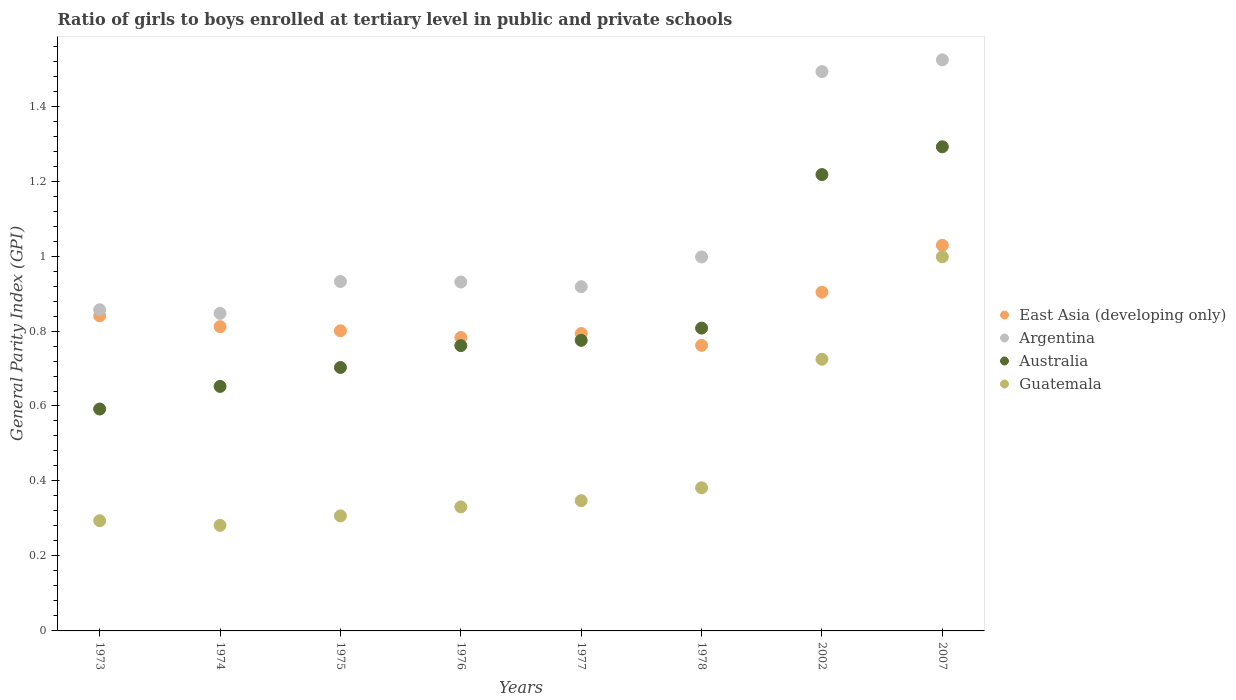How many different coloured dotlines are there?
Your answer should be very brief. 4. What is the general parity index in Australia in 2002?
Your answer should be compact. 1.22. Across all years, what is the maximum general parity index in East Asia (developing only)?
Provide a short and direct response. 1.03. Across all years, what is the minimum general parity index in Australia?
Provide a short and direct response. 0.59. In which year was the general parity index in Australia minimum?
Offer a very short reply. 1973. What is the total general parity index in East Asia (developing only) in the graph?
Provide a succinct answer. 6.72. What is the difference between the general parity index in Australia in 1978 and that in 2007?
Ensure brevity in your answer.  -0.48. What is the difference between the general parity index in Argentina in 1973 and the general parity index in East Asia (developing only) in 1976?
Provide a short and direct response. 0.07. What is the average general parity index in Guatemala per year?
Your answer should be compact. 0.46. In the year 2002, what is the difference between the general parity index in Australia and general parity index in Argentina?
Your response must be concise. -0.27. What is the ratio of the general parity index in Guatemala in 1974 to that in 1978?
Offer a very short reply. 0.74. Is the difference between the general parity index in Australia in 1973 and 1977 greater than the difference between the general parity index in Argentina in 1973 and 1977?
Ensure brevity in your answer.  No. What is the difference between the highest and the second highest general parity index in East Asia (developing only)?
Keep it short and to the point. 0.13. What is the difference between the highest and the lowest general parity index in Australia?
Make the answer very short. 0.7. In how many years, is the general parity index in Australia greater than the average general parity index in Australia taken over all years?
Your response must be concise. 2. Is it the case that in every year, the sum of the general parity index in East Asia (developing only) and general parity index in Argentina  is greater than the general parity index in Guatemala?
Make the answer very short. Yes. Is the general parity index in East Asia (developing only) strictly greater than the general parity index in Australia over the years?
Ensure brevity in your answer.  No. What is the difference between two consecutive major ticks on the Y-axis?
Provide a short and direct response. 0.2. Where does the legend appear in the graph?
Your response must be concise. Center right. How many legend labels are there?
Make the answer very short. 4. What is the title of the graph?
Provide a succinct answer. Ratio of girls to boys enrolled at tertiary level in public and private schools. What is the label or title of the X-axis?
Offer a very short reply. Years. What is the label or title of the Y-axis?
Keep it short and to the point. General Parity Index (GPI). What is the General Parity Index (GPI) in East Asia (developing only) in 1973?
Your response must be concise. 0.84. What is the General Parity Index (GPI) in Argentina in 1973?
Keep it short and to the point. 0.86. What is the General Parity Index (GPI) in Australia in 1973?
Make the answer very short. 0.59. What is the General Parity Index (GPI) in Guatemala in 1973?
Ensure brevity in your answer.  0.29. What is the General Parity Index (GPI) of East Asia (developing only) in 1974?
Your answer should be very brief. 0.81. What is the General Parity Index (GPI) in Argentina in 1974?
Your answer should be compact. 0.85. What is the General Parity Index (GPI) in Australia in 1974?
Provide a short and direct response. 0.65. What is the General Parity Index (GPI) of Guatemala in 1974?
Make the answer very short. 0.28. What is the General Parity Index (GPI) of East Asia (developing only) in 1975?
Give a very brief answer. 0.8. What is the General Parity Index (GPI) in Argentina in 1975?
Make the answer very short. 0.93. What is the General Parity Index (GPI) in Australia in 1975?
Ensure brevity in your answer.  0.7. What is the General Parity Index (GPI) in Guatemala in 1975?
Offer a terse response. 0.31. What is the General Parity Index (GPI) of East Asia (developing only) in 1976?
Give a very brief answer. 0.78. What is the General Parity Index (GPI) in Argentina in 1976?
Make the answer very short. 0.93. What is the General Parity Index (GPI) in Australia in 1976?
Offer a very short reply. 0.76. What is the General Parity Index (GPI) in Guatemala in 1976?
Provide a succinct answer. 0.33. What is the General Parity Index (GPI) of East Asia (developing only) in 1977?
Keep it short and to the point. 0.79. What is the General Parity Index (GPI) of Argentina in 1977?
Give a very brief answer. 0.92. What is the General Parity Index (GPI) in Australia in 1977?
Keep it short and to the point. 0.78. What is the General Parity Index (GPI) in Guatemala in 1977?
Offer a very short reply. 0.35. What is the General Parity Index (GPI) of East Asia (developing only) in 1978?
Keep it short and to the point. 0.76. What is the General Parity Index (GPI) of Argentina in 1978?
Give a very brief answer. 1. What is the General Parity Index (GPI) of Australia in 1978?
Keep it short and to the point. 0.81. What is the General Parity Index (GPI) in Guatemala in 1978?
Make the answer very short. 0.38. What is the General Parity Index (GPI) in East Asia (developing only) in 2002?
Provide a succinct answer. 0.9. What is the General Parity Index (GPI) of Argentina in 2002?
Ensure brevity in your answer.  1.49. What is the General Parity Index (GPI) of Australia in 2002?
Keep it short and to the point. 1.22. What is the General Parity Index (GPI) in Guatemala in 2002?
Offer a very short reply. 0.72. What is the General Parity Index (GPI) of East Asia (developing only) in 2007?
Your response must be concise. 1.03. What is the General Parity Index (GPI) of Argentina in 2007?
Ensure brevity in your answer.  1.52. What is the General Parity Index (GPI) in Australia in 2007?
Your answer should be very brief. 1.29. What is the General Parity Index (GPI) of Guatemala in 2007?
Offer a very short reply. 1. Across all years, what is the maximum General Parity Index (GPI) of East Asia (developing only)?
Keep it short and to the point. 1.03. Across all years, what is the maximum General Parity Index (GPI) in Argentina?
Make the answer very short. 1.52. Across all years, what is the maximum General Parity Index (GPI) in Australia?
Your answer should be very brief. 1.29. Across all years, what is the maximum General Parity Index (GPI) in Guatemala?
Offer a terse response. 1. Across all years, what is the minimum General Parity Index (GPI) in East Asia (developing only)?
Provide a short and direct response. 0.76. Across all years, what is the minimum General Parity Index (GPI) of Argentina?
Your response must be concise. 0.85. Across all years, what is the minimum General Parity Index (GPI) in Australia?
Provide a succinct answer. 0.59. Across all years, what is the minimum General Parity Index (GPI) of Guatemala?
Provide a succinct answer. 0.28. What is the total General Parity Index (GPI) of East Asia (developing only) in the graph?
Offer a terse response. 6.72. What is the total General Parity Index (GPI) of Argentina in the graph?
Provide a succinct answer. 8.5. What is the total General Parity Index (GPI) of Australia in the graph?
Offer a very short reply. 6.8. What is the total General Parity Index (GPI) in Guatemala in the graph?
Your response must be concise. 3.67. What is the difference between the General Parity Index (GPI) of East Asia (developing only) in 1973 and that in 1974?
Make the answer very short. 0.03. What is the difference between the General Parity Index (GPI) in Argentina in 1973 and that in 1974?
Give a very brief answer. 0.01. What is the difference between the General Parity Index (GPI) in Australia in 1973 and that in 1974?
Keep it short and to the point. -0.06. What is the difference between the General Parity Index (GPI) of Guatemala in 1973 and that in 1974?
Give a very brief answer. 0.01. What is the difference between the General Parity Index (GPI) in East Asia (developing only) in 1973 and that in 1975?
Ensure brevity in your answer.  0.04. What is the difference between the General Parity Index (GPI) in Argentina in 1973 and that in 1975?
Keep it short and to the point. -0.08. What is the difference between the General Parity Index (GPI) of Australia in 1973 and that in 1975?
Give a very brief answer. -0.11. What is the difference between the General Parity Index (GPI) of Guatemala in 1973 and that in 1975?
Give a very brief answer. -0.01. What is the difference between the General Parity Index (GPI) of East Asia (developing only) in 1973 and that in 1976?
Your answer should be very brief. 0.06. What is the difference between the General Parity Index (GPI) in Argentina in 1973 and that in 1976?
Make the answer very short. -0.07. What is the difference between the General Parity Index (GPI) of Australia in 1973 and that in 1976?
Give a very brief answer. -0.17. What is the difference between the General Parity Index (GPI) in Guatemala in 1973 and that in 1976?
Provide a short and direct response. -0.04. What is the difference between the General Parity Index (GPI) in East Asia (developing only) in 1973 and that in 1977?
Your answer should be very brief. 0.05. What is the difference between the General Parity Index (GPI) in Argentina in 1973 and that in 1977?
Make the answer very short. -0.06. What is the difference between the General Parity Index (GPI) in Australia in 1973 and that in 1977?
Your response must be concise. -0.18. What is the difference between the General Parity Index (GPI) in Guatemala in 1973 and that in 1977?
Give a very brief answer. -0.05. What is the difference between the General Parity Index (GPI) of East Asia (developing only) in 1973 and that in 1978?
Your answer should be very brief. 0.08. What is the difference between the General Parity Index (GPI) of Argentina in 1973 and that in 1978?
Make the answer very short. -0.14. What is the difference between the General Parity Index (GPI) of Australia in 1973 and that in 1978?
Provide a short and direct response. -0.22. What is the difference between the General Parity Index (GPI) of Guatemala in 1973 and that in 1978?
Your response must be concise. -0.09. What is the difference between the General Parity Index (GPI) of East Asia (developing only) in 1973 and that in 2002?
Your answer should be compact. -0.06. What is the difference between the General Parity Index (GPI) of Argentina in 1973 and that in 2002?
Offer a very short reply. -0.64. What is the difference between the General Parity Index (GPI) of Australia in 1973 and that in 2002?
Keep it short and to the point. -0.63. What is the difference between the General Parity Index (GPI) of Guatemala in 1973 and that in 2002?
Make the answer very short. -0.43. What is the difference between the General Parity Index (GPI) of East Asia (developing only) in 1973 and that in 2007?
Ensure brevity in your answer.  -0.19. What is the difference between the General Parity Index (GPI) in Australia in 1973 and that in 2007?
Your response must be concise. -0.7. What is the difference between the General Parity Index (GPI) in Guatemala in 1973 and that in 2007?
Make the answer very short. -0.7. What is the difference between the General Parity Index (GPI) in East Asia (developing only) in 1974 and that in 1975?
Keep it short and to the point. 0.01. What is the difference between the General Parity Index (GPI) in Argentina in 1974 and that in 1975?
Offer a very short reply. -0.09. What is the difference between the General Parity Index (GPI) of Australia in 1974 and that in 1975?
Make the answer very short. -0.05. What is the difference between the General Parity Index (GPI) in Guatemala in 1974 and that in 1975?
Provide a succinct answer. -0.03. What is the difference between the General Parity Index (GPI) in East Asia (developing only) in 1974 and that in 1976?
Your response must be concise. 0.03. What is the difference between the General Parity Index (GPI) of Argentina in 1974 and that in 1976?
Your response must be concise. -0.08. What is the difference between the General Parity Index (GPI) in Australia in 1974 and that in 1976?
Your response must be concise. -0.11. What is the difference between the General Parity Index (GPI) of Guatemala in 1974 and that in 1976?
Offer a very short reply. -0.05. What is the difference between the General Parity Index (GPI) in East Asia (developing only) in 1974 and that in 1977?
Provide a short and direct response. 0.02. What is the difference between the General Parity Index (GPI) of Argentina in 1974 and that in 1977?
Make the answer very short. -0.07. What is the difference between the General Parity Index (GPI) of Australia in 1974 and that in 1977?
Offer a terse response. -0.12. What is the difference between the General Parity Index (GPI) of Guatemala in 1974 and that in 1977?
Keep it short and to the point. -0.07. What is the difference between the General Parity Index (GPI) in East Asia (developing only) in 1974 and that in 1978?
Your answer should be compact. 0.05. What is the difference between the General Parity Index (GPI) of Argentina in 1974 and that in 1978?
Offer a very short reply. -0.15. What is the difference between the General Parity Index (GPI) in Australia in 1974 and that in 1978?
Your answer should be compact. -0.16. What is the difference between the General Parity Index (GPI) in Guatemala in 1974 and that in 1978?
Make the answer very short. -0.1. What is the difference between the General Parity Index (GPI) in East Asia (developing only) in 1974 and that in 2002?
Give a very brief answer. -0.09. What is the difference between the General Parity Index (GPI) in Argentina in 1974 and that in 2002?
Give a very brief answer. -0.65. What is the difference between the General Parity Index (GPI) of Australia in 1974 and that in 2002?
Your answer should be very brief. -0.57. What is the difference between the General Parity Index (GPI) in Guatemala in 1974 and that in 2002?
Make the answer very short. -0.44. What is the difference between the General Parity Index (GPI) in East Asia (developing only) in 1974 and that in 2007?
Provide a succinct answer. -0.22. What is the difference between the General Parity Index (GPI) of Argentina in 1974 and that in 2007?
Your response must be concise. -0.68. What is the difference between the General Parity Index (GPI) in Australia in 1974 and that in 2007?
Your response must be concise. -0.64. What is the difference between the General Parity Index (GPI) in Guatemala in 1974 and that in 2007?
Offer a terse response. -0.72. What is the difference between the General Parity Index (GPI) in East Asia (developing only) in 1975 and that in 1976?
Offer a terse response. 0.02. What is the difference between the General Parity Index (GPI) of Argentina in 1975 and that in 1976?
Your answer should be very brief. 0. What is the difference between the General Parity Index (GPI) of Australia in 1975 and that in 1976?
Provide a short and direct response. -0.06. What is the difference between the General Parity Index (GPI) of Guatemala in 1975 and that in 1976?
Offer a very short reply. -0.02. What is the difference between the General Parity Index (GPI) of East Asia (developing only) in 1975 and that in 1977?
Provide a short and direct response. 0.01. What is the difference between the General Parity Index (GPI) in Argentina in 1975 and that in 1977?
Your response must be concise. 0.01. What is the difference between the General Parity Index (GPI) in Australia in 1975 and that in 1977?
Your answer should be compact. -0.07. What is the difference between the General Parity Index (GPI) of Guatemala in 1975 and that in 1977?
Your answer should be compact. -0.04. What is the difference between the General Parity Index (GPI) in East Asia (developing only) in 1975 and that in 1978?
Your answer should be very brief. 0.04. What is the difference between the General Parity Index (GPI) of Argentina in 1975 and that in 1978?
Offer a very short reply. -0.07. What is the difference between the General Parity Index (GPI) in Australia in 1975 and that in 1978?
Give a very brief answer. -0.1. What is the difference between the General Parity Index (GPI) in Guatemala in 1975 and that in 1978?
Give a very brief answer. -0.07. What is the difference between the General Parity Index (GPI) of East Asia (developing only) in 1975 and that in 2002?
Give a very brief answer. -0.1. What is the difference between the General Parity Index (GPI) of Argentina in 1975 and that in 2002?
Give a very brief answer. -0.56. What is the difference between the General Parity Index (GPI) of Australia in 1975 and that in 2002?
Provide a short and direct response. -0.51. What is the difference between the General Parity Index (GPI) of Guatemala in 1975 and that in 2002?
Your answer should be compact. -0.42. What is the difference between the General Parity Index (GPI) of East Asia (developing only) in 1975 and that in 2007?
Provide a succinct answer. -0.23. What is the difference between the General Parity Index (GPI) in Argentina in 1975 and that in 2007?
Make the answer very short. -0.59. What is the difference between the General Parity Index (GPI) in Australia in 1975 and that in 2007?
Provide a succinct answer. -0.59. What is the difference between the General Parity Index (GPI) in Guatemala in 1975 and that in 2007?
Your answer should be very brief. -0.69. What is the difference between the General Parity Index (GPI) of East Asia (developing only) in 1976 and that in 1977?
Keep it short and to the point. -0.01. What is the difference between the General Parity Index (GPI) of Argentina in 1976 and that in 1977?
Make the answer very short. 0.01. What is the difference between the General Parity Index (GPI) of Australia in 1976 and that in 1977?
Provide a short and direct response. -0.01. What is the difference between the General Parity Index (GPI) in Guatemala in 1976 and that in 1977?
Make the answer very short. -0.02. What is the difference between the General Parity Index (GPI) in East Asia (developing only) in 1976 and that in 1978?
Offer a very short reply. 0.02. What is the difference between the General Parity Index (GPI) in Argentina in 1976 and that in 1978?
Your response must be concise. -0.07. What is the difference between the General Parity Index (GPI) of Australia in 1976 and that in 1978?
Offer a very short reply. -0.05. What is the difference between the General Parity Index (GPI) in Guatemala in 1976 and that in 1978?
Your response must be concise. -0.05. What is the difference between the General Parity Index (GPI) in East Asia (developing only) in 1976 and that in 2002?
Your answer should be very brief. -0.12. What is the difference between the General Parity Index (GPI) in Argentina in 1976 and that in 2002?
Provide a succinct answer. -0.56. What is the difference between the General Parity Index (GPI) of Australia in 1976 and that in 2002?
Your answer should be very brief. -0.46. What is the difference between the General Parity Index (GPI) in Guatemala in 1976 and that in 2002?
Your response must be concise. -0.39. What is the difference between the General Parity Index (GPI) of East Asia (developing only) in 1976 and that in 2007?
Keep it short and to the point. -0.25. What is the difference between the General Parity Index (GPI) in Argentina in 1976 and that in 2007?
Provide a short and direct response. -0.59. What is the difference between the General Parity Index (GPI) in Australia in 1976 and that in 2007?
Provide a short and direct response. -0.53. What is the difference between the General Parity Index (GPI) of Guatemala in 1976 and that in 2007?
Provide a succinct answer. -0.67. What is the difference between the General Parity Index (GPI) in East Asia (developing only) in 1977 and that in 1978?
Provide a short and direct response. 0.03. What is the difference between the General Parity Index (GPI) in Argentina in 1977 and that in 1978?
Your answer should be very brief. -0.08. What is the difference between the General Parity Index (GPI) of Australia in 1977 and that in 1978?
Offer a very short reply. -0.03. What is the difference between the General Parity Index (GPI) of Guatemala in 1977 and that in 1978?
Your answer should be very brief. -0.03. What is the difference between the General Parity Index (GPI) in East Asia (developing only) in 1977 and that in 2002?
Make the answer very short. -0.11. What is the difference between the General Parity Index (GPI) of Argentina in 1977 and that in 2002?
Provide a succinct answer. -0.57. What is the difference between the General Parity Index (GPI) of Australia in 1977 and that in 2002?
Ensure brevity in your answer.  -0.44. What is the difference between the General Parity Index (GPI) in Guatemala in 1977 and that in 2002?
Offer a very short reply. -0.38. What is the difference between the General Parity Index (GPI) of East Asia (developing only) in 1977 and that in 2007?
Keep it short and to the point. -0.24. What is the difference between the General Parity Index (GPI) in Argentina in 1977 and that in 2007?
Ensure brevity in your answer.  -0.61. What is the difference between the General Parity Index (GPI) of Australia in 1977 and that in 2007?
Provide a short and direct response. -0.52. What is the difference between the General Parity Index (GPI) of Guatemala in 1977 and that in 2007?
Keep it short and to the point. -0.65. What is the difference between the General Parity Index (GPI) of East Asia (developing only) in 1978 and that in 2002?
Provide a short and direct response. -0.14. What is the difference between the General Parity Index (GPI) of Argentina in 1978 and that in 2002?
Provide a short and direct response. -0.49. What is the difference between the General Parity Index (GPI) of Australia in 1978 and that in 2002?
Your answer should be compact. -0.41. What is the difference between the General Parity Index (GPI) of Guatemala in 1978 and that in 2002?
Offer a very short reply. -0.34. What is the difference between the General Parity Index (GPI) of East Asia (developing only) in 1978 and that in 2007?
Make the answer very short. -0.27. What is the difference between the General Parity Index (GPI) in Argentina in 1978 and that in 2007?
Provide a short and direct response. -0.53. What is the difference between the General Parity Index (GPI) of Australia in 1978 and that in 2007?
Your answer should be compact. -0.48. What is the difference between the General Parity Index (GPI) of Guatemala in 1978 and that in 2007?
Provide a short and direct response. -0.62. What is the difference between the General Parity Index (GPI) of East Asia (developing only) in 2002 and that in 2007?
Give a very brief answer. -0.13. What is the difference between the General Parity Index (GPI) of Argentina in 2002 and that in 2007?
Make the answer very short. -0.03. What is the difference between the General Parity Index (GPI) of Australia in 2002 and that in 2007?
Give a very brief answer. -0.07. What is the difference between the General Parity Index (GPI) of Guatemala in 2002 and that in 2007?
Offer a terse response. -0.27. What is the difference between the General Parity Index (GPI) in East Asia (developing only) in 1973 and the General Parity Index (GPI) in Argentina in 1974?
Your answer should be very brief. -0.01. What is the difference between the General Parity Index (GPI) in East Asia (developing only) in 1973 and the General Parity Index (GPI) in Australia in 1974?
Your answer should be compact. 0.19. What is the difference between the General Parity Index (GPI) in East Asia (developing only) in 1973 and the General Parity Index (GPI) in Guatemala in 1974?
Make the answer very short. 0.56. What is the difference between the General Parity Index (GPI) in Argentina in 1973 and the General Parity Index (GPI) in Australia in 1974?
Your answer should be compact. 0.2. What is the difference between the General Parity Index (GPI) in Argentina in 1973 and the General Parity Index (GPI) in Guatemala in 1974?
Your response must be concise. 0.58. What is the difference between the General Parity Index (GPI) in Australia in 1973 and the General Parity Index (GPI) in Guatemala in 1974?
Your answer should be compact. 0.31. What is the difference between the General Parity Index (GPI) in East Asia (developing only) in 1973 and the General Parity Index (GPI) in Argentina in 1975?
Provide a short and direct response. -0.09. What is the difference between the General Parity Index (GPI) of East Asia (developing only) in 1973 and the General Parity Index (GPI) of Australia in 1975?
Your answer should be compact. 0.14. What is the difference between the General Parity Index (GPI) in East Asia (developing only) in 1973 and the General Parity Index (GPI) in Guatemala in 1975?
Your answer should be compact. 0.53. What is the difference between the General Parity Index (GPI) in Argentina in 1973 and the General Parity Index (GPI) in Australia in 1975?
Make the answer very short. 0.15. What is the difference between the General Parity Index (GPI) in Argentina in 1973 and the General Parity Index (GPI) in Guatemala in 1975?
Keep it short and to the point. 0.55. What is the difference between the General Parity Index (GPI) of Australia in 1973 and the General Parity Index (GPI) of Guatemala in 1975?
Provide a succinct answer. 0.28. What is the difference between the General Parity Index (GPI) in East Asia (developing only) in 1973 and the General Parity Index (GPI) in Argentina in 1976?
Provide a short and direct response. -0.09. What is the difference between the General Parity Index (GPI) in East Asia (developing only) in 1973 and the General Parity Index (GPI) in Australia in 1976?
Your answer should be very brief. 0.08. What is the difference between the General Parity Index (GPI) of East Asia (developing only) in 1973 and the General Parity Index (GPI) of Guatemala in 1976?
Give a very brief answer. 0.51. What is the difference between the General Parity Index (GPI) in Argentina in 1973 and the General Parity Index (GPI) in Australia in 1976?
Ensure brevity in your answer.  0.1. What is the difference between the General Parity Index (GPI) in Argentina in 1973 and the General Parity Index (GPI) in Guatemala in 1976?
Ensure brevity in your answer.  0.53. What is the difference between the General Parity Index (GPI) in Australia in 1973 and the General Parity Index (GPI) in Guatemala in 1976?
Your response must be concise. 0.26. What is the difference between the General Parity Index (GPI) in East Asia (developing only) in 1973 and the General Parity Index (GPI) in Argentina in 1977?
Your response must be concise. -0.08. What is the difference between the General Parity Index (GPI) in East Asia (developing only) in 1973 and the General Parity Index (GPI) in Australia in 1977?
Provide a short and direct response. 0.07. What is the difference between the General Parity Index (GPI) of East Asia (developing only) in 1973 and the General Parity Index (GPI) of Guatemala in 1977?
Offer a very short reply. 0.49. What is the difference between the General Parity Index (GPI) of Argentina in 1973 and the General Parity Index (GPI) of Australia in 1977?
Give a very brief answer. 0.08. What is the difference between the General Parity Index (GPI) of Argentina in 1973 and the General Parity Index (GPI) of Guatemala in 1977?
Provide a succinct answer. 0.51. What is the difference between the General Parity Index (GPI) in Australia in 1973 and the General Parity Index (GPI) in Guatemala in 1977?
Keep it short and to the point. 0.24. What is the difference between the General Parity Index (GPI) in East Asia (developing only) in 1973 and the General Parity Index (GPI) in Argentina in 1978?
Provide a short and direct response. -0.16. What is the difference between the General Parity Index (GPI) in East Asia (developing only) in 1973 and the General Parity Index (GPI) in Australia in 1978?
Your response must be concise. 0.03. What is the difference between the General Parity Index (GPI) in East Asia (developing only) in 1973 and the General Parity Index (GPI) in Guatemala in 1978?
Offer a terse response. 0.46. What is the difference between the General Parity Index (GPI) of Argentina in 1973 and the General Parity Index (GPI) of Australia in 1978?
Provide a short and direct response. 0.05. What is the difference between the General Parity Index (GPI) in Argentina in 1973 and the General Parity Index (GPI) in Guatemala in 1978?
Provide a short and direct response. 0.47. What is the difference between the General Parity Index (GPI) in Australia in 1973 and the General Parity Index (GPI) in Guatemala in 1978?
Make the answer very short. 0.21. What is the difference between the General Parity Index (GPI) of East Asia (developing only) in 1973 and the General Parity Index (GPI) of Argentina in 2002?
Make the answer very short. -0.65. What is the difference between the General Parity Index (GPI) of East Asia (developing only) in 1973 and the General Parity Index (GPI) of Australia in 2002?
Offer a very short reply. -0.38. What is the difference between the General Parity Index (GPI) in East Asia (developing only) in 1973 and the General Parity Index (GPI) in Guatemala in 2002?
Make the answer very short. 0.12. What is the difference between the General Parity Index (GPI) in Argentina in 1973 and the General Parity Index (GPI) in Australia in 2002?
Offer a terse response. -0.36. What is the difference between the General Parity Index (GPI) of Argentina in 1973 and the General Parity Index (GPI) of Guatemala in 2002?
Provide a succinct answer. 0.13. What is the difference between the General Parity Index (GPI) of Australia in 1973 and the General Parity Index (GPI) of Guatemala in 2002?
Your answer should be compact. -0.13. What is the difference between the General Parity Index (GPI) of East Asia (developing only) in 1973 and the General Parity Index (GPI) of Argentina in 2007?
Keep it short and to the point. -0.68. What is the difference between the General Parity Index (GPI) in East Asia (developing only) in 1973 and the General Parity Index (GPI) in Australia in 2007?
Your response must be concise. -0.45. What is the difference between the General Parity Index (GPI) of East Asia (developing only) in 1973 and the General Parity Index (GPI) of Guatemala in 2007?
Offer a very short reply. -0.16. What is the difference between the General Parity Index (GPI) of Argentina in 1973 and the General Parity Index (GPI) of Australia in 2007?
Offer a very short reply. -0.43. What is the difference between the General Parity Index (GPI) in Argentina in 1973 and the General Parity Index (GPI) in Guatemala in 2007?
Give a very brief answer. -0.14. What is the difference between the General Parity Index (GPI) in Australia in 1973 and the General Parity Index (GPI) in Guatemala in 2007?
Your answer should be very brief. -0.41. What is the difference between the General Parity Index (GPI) in East Asia (developing only) in 1974 and the General Parity Index (GPI) in Argentina in 1975?
Your response must be concise. -0.12. What is the difference between the General Parity Index (GPI) in East Asia (developing only) in 1974 and the General Parity Index (GPI) in Australia in 1975?
Give a very brief answer. 0.11. What is the difference between the General Parity Index (GPI) of East Asia (developing only) in 1974 and the General Parity Index (GPI) of Guatemala in 1975?
Ensure brevity in your answer.  0.5. What is the difference between the General Parity Index (GPI) in Argentina in 1974 and the General Parity Index (GPI) in Australia in 1975?
Give a very brief answer. 0.14. What is the difference between the General Parity Index (GPI) of Argentina in 1974 and the General Parity Index (GPI) of Guatemala in 1975?
Provide a succinct answer. 0.54. What is the difference between the General Parity Index (GPI) of Australia in 1974 and the General Parity Index (GPI) of Guatemala in 1975?
Make the answer very short. 0.35. What is the difference between the General Parity Index (GPI) in East Asia (developing only) in 1974 and the General Parity Index (GPI) in Argentina in 1976?
Offer a terse response. -0.12. What is the difference between the General Parity Index (GPI) in East Asia (developing only) in 1974 and the General Parity Index (GPI) in Australia in 1976?
Provide a short and direct response. 0.05. What is the difference between the General Parity Index (GPI) of East Asia (developing only) in 1974 and the General Parity Index (GPI) of Guatemala in 1976?
Make the answer very short. 0.48. What is the difference between the General Parity Index (GPI) of Argentina in 1974 and the General Parity Index (GPI) of Australia in 1976?
Provide a short and direct response. 0.09. What is the difference between the General Parity Index (GPI) in Argentina in 1974 and the General Parity Index (GPI) in Guatemala in 1976?
Provide a succinct answer. 0.52. What is the difference between the General Parity Index (GPI) in Australia in 1974 and the General Parity Index (GPI) in Guatemala in 1976?
Ensure brevity in your answer.  0.32. What is the difference between the General Parity Index (GPI) of East Asia (developing only) in 1974 and the General Parity Index (GPI) of Argentina in 1977?
Offer a terse response. -0.11. What is the difference between the General Parity Index (GPI) of East Asia (developing only) in 1974 and the General Parity Index (GPI) of Australia in 1977?
Make the answer very short. 0.04. What is the difference between the General Parity Index (GPI) of East Asia (developing only) in 1974 and the General Parity Index (GPI) of Guatemala in 1977?
Offer a very short reply. 0.46. What is the difference between the General Parity Index (GPI) in Argentina in 1974 and the General Parity Index (GPI) in Australia in 1977?
Offer a very short reply. 0.07. What is the difference between the General Parity Index (GPI) of Argentina in 1974 and the General Parity Index (GPI) of Guatemala in 1977?
Ensure brevity in your answer.  0.5. What is the difference between the General Parity Index (GPI) of Australia in 1974 and the General Parity Index (GPI) of Guatemala in 1977?
Your answer should be compact. 0.3. What is the difference between the General Parity Index (GPI) in East Asia (developing only) in 1974 and the General Parity Index (GPI) in Argentina in 1978?
Keep it short and to the point. -0.19. What is the difference between the General Parity Index (GPI) of East Asia (developing only) in 1974 and the General Parity Index (GPI) of Australia in 1978?
Give a very brief answer. 0. What is the difference between the General Parity Index (GPI) of East Asia (developing only) in 1974 and the General Parity Index (GPI) of Guatemala in 1978?
Your answer should be compact. 0.43. What is the difference between the General Parity Index (GPI) of Argentina in 1974 and the General Parity Index (GPI) of Australia in 1978?
Offer a very short reply. 0.04. What is the difference between the General Parity Index (GPI) of Argentina in 1974 and the General Parity Index (GPI) of Guatemala in 1978?
Provide a short and direct response. 0.47. What is the difference between the General Parity Index (GPI) of Australia in 1974 and the General Parity Index (GPI) of Guatemala in 1978?
Provide a succinct answer. 0.27. What is the difference between the General Parity Index (GPI) in East Asia (developing only) in 1974 and the General Parity Index (GPI) in Argentina in 2002?
Your answer should be very brief. -0.68. What is the difference between the General Parity Index (GPI) of East Asia (developing only) in 1974 and the General Parity Index (GPI) of Australia in 2002?
Your answer should be very brief. -0.41. What is the difference between the General Parity Index (GPI) of East Asia (developing only) in 1974 and the General Parity Index (GPI) of Guatemala in 2002?
Provide a succinct answer. 0.09. What is the difference between the General Parity Index (GPI) in Argentina in 1974 and the General Parity Index (GPI) in Australia in 2002?
Keep it short and to the point. -0.37. What is the difference between the General Parity Index (GPI) in Argentina in 1974 and the General Parity Index (GPI) in Guatemala in 2002?
Make the answer very short. 0.12. What is the difference between the General Parity Index (GPI) of Australia in 1974 and the General Parity Index (GPI) of Guatemala in 2002?
Offer a terse response. -0.07. What is the difference between the General Parity Index (GPI) of East Asia (developing only) in 1974 and the General Parity Index (GPI) of Argentina in 2007?
Ensure brevity in your answer.  -0.71. What is the difference between the General Parity Index (GPI) in East Asia (developing only) in 1974 and the General Parity Index (GPI) in Australia in 2007?
Your response must be concise. -0.48. What is the difference between the General Parity Index (GPI) in East Asia (developing only) in 1974 and the General Parity Index (GPI) in Guatemala in 2007?
Offer a terse response. -0.19. What is the difference between the General Parity Index (GPI) in Argentina in 1974 and the General Parity Index (GPI) in Australia in 2007?
Give a very brief answer. -0.44. What is the difference between the General Parity Index (GPI) of Argentina in 1974 and the General Parity Index (GPI) of Guatemala in 2007?
Keep it short and to the point. -0.15. What is the difference between the General Parity Index (GPI) in Australia in 1974 and the General Parity Index (GPI) in Guatemala in 2007?
Your response must be concise. -0.35. What is the difference between the General Parity Index (GPI) of East Asia (developing only) in 1975 and the General Parity Index (GPI) of Argentina in 1976?
Offer a terse response. -0.13. What is the difference between the General Parity Index (GPI) of East Asia (developing only) in 1975 and the General Parity Index (GPI) of Australia in 1976?
Make the answer very short. 0.04. What is the difference between the General Parity Index (GPI) in East Asia (developing only) in 1975 and the General Parity Index (GPI) in Guatemala in 1976?
Ensure brevity in your answer.  0.47. What is the difference between the General Parity Index (GPI) in Argentina in 1975 and the General Parity Index (GPI) in Australia in 1976?
Keep it short and to the point. 0.17. What is the difference between the General Parity Index (GPI) in Argentina in 1975 and the General Parity Index (GPI) in Guatemala in 1976?
Offer a very short reply. 0.6. What is the difference between the General Parity Index (GPI) in Australia in 1975 and the General Parity Index (GPI) in Guatemala in 1976?
Make the answer very short. 0.37. What is the difference between the General Parity Index (GPI) in East Asia (developing only) in 1975 and the General Parity Index (GPI) in Argentina in 1977?
Your answer should be compact. -0.12. What is the difference between the General Parity Index (GPI) in East Asia (developing only) in 1975 and the General Parity Index (GPI) in Australia in 1977?
Make the answer very short. 0.03. What is the difference between the General Parity Index (GPI) of East Asia (developing only) in 1975 and the General Parity Index (GPI) of Guatemala in 1977?
Your answer should be very brief. 0.45. What is the difference between the General Parity Index (GPI) in Argentina in 1975 and the General Parity Index (GPI) in Australia in 1977?
Provide a succinct answer. 0.16. What is the difference between the General Parity Index (GPI) of Argentina in 1975 and the General Parity Index (GPI) of Guatemala in 1977?
Offer a very short reply. 0.58. What is the difference between the General Parity Index (GPI) of Australia in 1975 and the General Parity Index (GPI) of Guatemala in 1977?
Your answer should be compact. 0.36. What is the difference between the General Parity Index (GPI) of East Asia (developing only) in 1975 and the General Parity Index (GPI) of Argentina in 1978?
Provide a succinct answer. -0.2. What is the difference between the General Parity Index (GPI) in East Asia (developing only) in 1975 and the General Parity Index (GPI) in Australia in 1978?
Give a very brief answer. -0.01. What is the difference between the General Parity Index (GPI) in East Asia (developing only) in 1975 and the General Parity Index (GPI) in Guatemala in 1978?
Provide a succinct answer. 0.42. What is the difference between the General Parity Index (GPI) of Argentina in 1975 and the General Parity Index (GPI) of Australia in 1978?
Your answer should be very brief. 0.12. What is the difference between the General Parity Index (GPI) of Argentina in 1975 and the General Parity Index (GPI) of Guatemala in 1978?
Give a very brief answer. 0.55. What is the difference between the General Parity Index (GPI) in Australia in 1975 and the General Parity Index (GPI) in Guatemala in 1978?
Keep it short and to the point. 0.32. What is the difference between the General Parity Index (GPI) of East Asia (developing only) in 1975 and the General Parity Index (GPI) of Argentina in 2002?
Make the answer very short. -0.69. What is the difference between the General Parity Index (GPI) in East Asia (developing only) in 1975 and the General Parity Index (GPI) in Australia in 2002?
Keep it short and to the point. -0.42. What is the difference between the General Parity Index (GPI) of East Asia (developing only) in 1975 and the General Parity Index (GPI) of Guatemala in 2002?
Provide a short and direct response. 0.08. What is the difference between the General Parity Index (GPI) of Argentina in 1975 and the General Parity Index (GPI) of Australia in 2002?
Keep it short and to the point. -0.29. What is the difference between the General Parity Index (GPI) of Argentina in 1975 and the General Parity Index (GPI) of Guatemala in 2002?
Offer a terse response. 0.21. What is the difference between the General Parity Index (GPI) in Australia in 1975 and the General Parity Index (GPI) in Guatemala in 2002?
Ensure brevity in your answer.  -0.02. What is the difference between the General Parity Index (GPI) in East Asia (developing only) in 1975 and the General Parity Index (GPI) in Argentina in 2007?
Offer a very short reply. -0.72. What is the difference between the General Parity Index (GPI) in East Asia (developing only) in 1975 and the General Parity Index (GPI) in Australia in 2007?
Your answer should be compact. -0.49. What is the difference between the General Parity Index (GPI) of East Asia (developing only) in 1975 and the General Parity Index (GPI) of Guatemala in 2007?
Provide a succinct answer. -0.2. What is the difference between the General Parity Index (GPI) of Argentina in 1975 and the General Parity Index (GPI) of Australia in 2007?
Ensure brevity in your answer.  -0.36. What is the difference between the General Parity Index (GPI) of Argentina in 1975 and the General Parity Index (GPI) of Guatemala in 2007?
Keep it short and to the point. -0.07. What is the difference between the General Parity Index (GPI) of Australia in 1975 and the General Parity Index (GPI) of Guatemala in 2007?
Give a very brief answer. -0.3. What is the difference between the General Parity Index (GPI) of East Asia (developing only) in 1976 and the General Parity Index (GPI) of Argentina in 1977?
Your answer should be very brief. -0.14. What is the difference between the General Parity Index (GPI) in East Asia (developing only) in 1976 and the General Parity Index (GPI) in Australia in 1977?
Your answer should be compact. 0.01. What is the difference between the General Parity Index (GPI) in East Asia (developing only) in 1976 and the General Parity Index (GPI) in Guatemala in 1977?
Your answer should be compact. 0.44. What is the difference between the General Parity Index (GPI) in Argentina in 1976 and the General Parity Index (GPI) in Australia in 1977?
Your answer should be very brief. 0.16. What is the difference between the General Parity Index (GPI) of Argentina in 1976 and the General Parity Index (GPI) of Guatemala in 1977?
Ensure brevity in your answer.  0.58. What is the difference between the General Parity Index (GPI) of Australia in 1976 and the General Parity Index (GPI) of Guatemala in 1977?
Provide a short and direct response. 0.41. What is the difference between the General Parity Index (GPI) in East Asia (developing only) in 1976 and the General Parity Index (GPI) in Argentina in 1978?
Give a very brief answer. -0.21. What is the difference between the General Parity Index (GPI) in East Asia (developing only) in 1976 and the General Parity Index (GPI) in Australia in 1978?
Provide a succinct answer. -0.03. What is the difference between the General Parity Index (GPI) in East Asia (developing only) in 1976 and the General Parity Index (GPI) in Guatemala in 1978?
Your answer should be very brief. 0.4. What is the difference between the General Parity Index (GPI) of Argentina in 1976 and the General Parity Index (GPI) of Australia in 1978?
Give a very brief answer. 0.12. What is the difference between the General Parity Index (GPI) in Argentina in 1976 and the General Parity Index (GPI) in Guatemala in 1978?
Keep it short and to the point. 0.55. What is the difference between the General Parity Index (GPI) in Australia in 1976 and the General Parity Index (GPI) in Guatemala in 1978?
Your response must be concise. 0.38. What is the difference between the General Parity Index (GPI) of East Asia (developing only) in 1976 and the General Parity Index (GPI) of Argentina in 2002?
Keep it short and to the point. -0.71. What is the difference between the General Parity Index (GPI) of East Asia (developing only) in 1976 and the General Parity Index (GPI) of Australia in 2002?
Keep it short and to the point. -0.43. What is the difference between the General Parity Index (GPI) in East Asia (developing only) in 1976 and the General Parity Index (GPI) in Guatemala in 2002?
Make the answer very short. 0.06. What is the difference between the General Parity Index (GPI) of Argentina in 1976 and the General Parity Index (GPI) of Australia in 2002?
Offer a terse response. -0.29. What is the difference between the General Parity Index (GPI) of Argentina in 1976 and the General Parity Index (GPI) of Guatemala in 2002?
Make the answer very short. 0.21. What is the difference between the General Parity Index (GPI) in Australia in 1976 and the General Parity Index (GPI) in Guatemala in 2002?
Your response must be concise. 0.04. What is the difference between the General Parity Index (GPI) in East Asia (developing only) in 1976 and the General Parity Index (GPI) in Argentina in 2007?
Your response must be concise. -0.74. What is the difference between the General Parity Index (GPI) in East Asia (developing only) in 1976 and the General Parity Index (GPI) in Australia in 2007?
Offer a very short reply. -0.51. What is the difference between the General Parity Index (GPI) in East Asia (developing only) in 1976 and the General Parity Index (GPI) in Guatemala in 2007?
Keep it short and to the point. -0.22. What is the difference between the General Parity Index (GPI) of Argentina in 1976 and the General Parity Index (GPI) of Australia in 2007?
Offer a very short reply. -0.36. What is the difference between the General Parity Index (GPI) in Argentina in 1976 and the General Parity Index (GPI) in Guatemala in 2007?
Give a very brief answer. -0.07. What is the difference between the General Parity Index (GPI) in Australia in 1976 and the General Parity Index (GPI) in Guatemala in 2007?
Make the answer very short. -0.24. What is the difference between the General Parity Index (GPI) of East Asia (developing only) in 1977 and the General Parity Index (GPI) of Argentina in 1978?
Your answer should be compact. -0.2. What is the difference between the General Parity Index (GPI) in East Asia (developing only) in 1977 and the General Parity Index (GPI) in Australia in 1978?
Provide a succinct answer. -0.01. What is the difference between the General Parity Index (GPI) of East Asia (developing only) in 1977 and the General Parity Index (GPI) of Guatemala in 1978?
Keep it short and to the point. 0.41. What is the difference between the General Parity Index (GPI) in Argentina in 1977 and the General Parity Index (GPI) in Australia in 1978?
Make the answer very short. 0.11. What is the difference between the General Parity Index (GPI) in Argentina in 1977 and the General Parity Index (GPI) in Guatemala in 1978?
Ensure brevity in your answer.  0.54. What is the difference between the General Parity Index (GPI) of Australia in 1977 and the General Parity Index (GPI) of Guatemala in 1978?
Offer a terse response. 0.39. What is the difference between the General Parity Index (GPI) of East Asia (developing only) in 1977 and the General Parity Index (GPI) of Argentina in 2002?
Offer a terse response. -0.7. What is the difference between the General Parity Index (GPI) of East Asia (developing only) in 1977 and the General Parity Index (GPI) of Australia in 2002?
Offer a terse response. -0.42. What is the difference between the General Parity Index (GPI) in East Asia (developing only) in 1977 and the General Parity Index (GPI) in Guatemala in 2002?
Your response must be concise. 0.07. What is the difference between the General Parity Index (GPI) in Argentina in 1977 and the General Parity Index (GPI) in Australia in 2002?
Make the answer very short. -0.3. What is the difference between the General Parity Index (GPI) in Argentina in 1977 and the General Parity Index (GPI) in Guatemala in 2002?
Make the answer very short. 0.19. What is the difference between the General Parity Index (GPI) of Australia in 1977 and the General Parity Index (GPI) of Guatemala in 2002?
Offer a very short reply. 0.05. What is the difference between the General Parity Index (GPI) in East Asia (developing only) in 1977 and the General Parity Index (GPI) in Argentina in 2007?
Your answer should be compact. -0.73. What is the difference between the General Parity Index (GPI) of East Asia (developing only) in 1977 and the General Parity Index (GPI) of Australia in 2007?
Offer a very short reply. -0.5. What is the difference between the General Parity Index (GPI) in East Asia (developing only) in 1977 and the General Parity Index (GPI) in Guatemala in 2007?
Ensure brevity in your answer.  -0.2. What is the difference between the General Parity Index (GPI) in Argentina in 1977 and the General Parity Index (GPI) in Australia in 2007?
Make the answer very short. -0.37. What is the difference between the General Parity Index (GPI) of Argentina in 1977 and the General Parity Index (GPI) of Guatemala in 2007?
Provide a short and direct response. -0.08. What is the difference between the General Parity Index (GPI) of Australia in 1977 and the General Parity Index (GPI) of Guatemala in 2007?
Your answer should be compact. -0.22. What is the difference between the General Parity Index (GPI) of East Asia (developing only) in 1978 and the General Parity Index (GPI) of Argentina in 2002?
Your answer should be compact. -0.73. What is the difference between the General Parity Index (GPI) in East Asia (developing only) in 1978 and the General Parity Index (GPI) in Australia in 2002?
Your answer should be compact. -0.46. What is the difference between the General Parity Index (GPI) of East Asia (developing only) in 1978 and the General Parity Index (GPI) of Guatemala in 2002?
Your answer should be very brief. 0.04. What is the difference between the General Parity Index (GPI) in Argentina in 1978 and the General Parity Index (GPI) in Australia in 2002?
Your answer should be very brief. -0.22. What is the difference between the General Parity Index (GPI) of Argentina in 1978 and the General Parity Index (GPI) of Guatemala in 2002?
Your answer should be compact. 0.27. What is the difference between the General Parity Index (GPI) of Australia in 1978 and the General Parity Index (GPI) of Guatemala in 2002?
Make the answer very short. 0.08. What is the difference between the General Parity Index (GPI) of East Asia (developing only) in 1978 and the General Parity Index (GPI) of Argentina in 2007?
Your answer should be very brief. -0.76. What is the difference between the General Parity Index (GPI) in East Asia (developing only) in 1978 and the General Parity Index (GPI) in Australia in 2007?
Provide a succinct answer. -0.53. What is the difference between the General Parity Index (GPI) in East Asia (developing only) in 1978 and the General Parity Index (GPI) in Guatemala in 2007?
Make the answer very short. -0.24. What is the difference between the General Parity Index (GPI) of Argentina in 1978 and the General Parity Index (GPI) of Australia in 2007?
Make the answer very short. -0.29. What is the difference between the General Parity Index (GPI) of Argentina in 1978 and the General Parity Index (GPI) of Guatemala in 2007?
Keep it short and to the point. -0. What is the difference between the General Parity Index (GPI) of Australia in 1978 and the General Parity Index (GPI) of Guatemala in 2007?
Your answer should be compact. -0.19. What is the difference between the General Parity Index (GPI) in East Asia (developing only) in 2002 and the General Parity Index (GPI) in Argentina in 2007?
Give a very brief answer. -0.62. What is the difference between the General Parity Index (GPI) of East Asia (developing only) in 2002 and the General Parity Index (GPI) of Australia in 2007?
Make the answer very short. -0.39. What is the difference between the General Parity Index (GPI) of East Asia (developing only) in 2002 and the General Parity Index (GPI) of Guatemala in 2007?
Your answer should be compact. -0.09. What is the difference between the General Parity Index (GPI) in Argentina in 2002 and the General Parity Index (GPI) in Australia in 2007?
Give a very brief answer. 0.2. What is the difference between the General Parity Index (GPI) in Argentina in 2002 and the General Parity Index (GPI) in Guatemala in 2007?
Ensure brevity in your answer.  0.49. What is the difference between the General Parity Index (GPI) in Australia in 2002 and the General Parity Index (GPI) in Guatemala in 2007?
Give a very brief answer. 0.22. What is the average General Parity Index (GPI) of East Asia (developing only) per year?
Your response must be concise. 0.84. What is the average General Parity Index (GPI) in Argentina per year?
Offer a terse response. 1.06. What is the average General Parity Index (GPI) in Australia per year?
Give a very brief answer. 0.85. What is the average General Parity Index (GPI) of Guatemala per year?
Provide a succinct answer. 0.46. In the year 1973, what is the difference between the General Parity Index (GPI) in East Asia (developing only) and General Parity Index (GPI) in Argentina?
Your answer should be compact. -0.02. In the year 1973, what is the difference between the General Parity Index (GPI) of East Asia (developing only) and General Parity Index (GPI) of Australia?
Your answer should be very brief. 0.25. In the year 1973, what is the difference between the General Parity Index (GPI) in East Asia (developing only) and General Parity Index (GPI) in Guatemala?
Provide a succinct answer. 0.55. In the year 1973, what is the difference between the General Parity Index (GPI) in Argentina and General Parity Index (GPI) in Australia?
Give a very brief answer. 0.26. In the year 1973, what is the difference between the General Parity Index (GPI) in Argentina and General Parity Index (GPI) in Guatemala?
Your answer should be very brief. 0.56. In the year 1973, what is the difference between the General Parity Index (GPI) of Australia and General Parity Index (GPI) of Guatemala?
Your answer should be very brief. 0.3. In the year 1974, what is the difference between the General Parity Index (GPI) of East Asia (developing only) and General Parity Index (GPI) of Argentina?
Keep it short and to the point. -0.04. In the year 1974, what is the difference between the General Parity Index (GPI) in East Asia (developing only) and General Parity Index (GPI) in Australia?
Your answer should be compact. 0.16. In the year 1974, what is the difference between the General Parity Index (GPI) of East Asia (developing only) and General Parity Index (GPI) of Guatemala?
Provide a short and direct response. 0.53. In the year 1974, what is the difference between the General Parity Index (GPI) of Argentina and General Parity Index (GPI) of Australia?
Your response must be concise. 0.19. In the year 1974, what is the difference between the General Parity Index (GPI) of Argentina and General Parity Index (GPI) of Guatemala?
Offer a very short reply. 0.57. In the year 1974, what is the difference between the General Parity Index (GPI) in Australia and General Parity Index (GPI) in Guatemala?
Give a very brief answer. 0.37. In the year 1975, what is the difference between the General Parity Index (GPI) in East Asia (developing only) and General Parity Index (GPI) in Argentina?
Your answer should be very brief. -0.13. In the year 1975, what is the difference between the General Parity Index (GPI) in East Asia (developing only) and General Parity Index (GPI) in Australia?
Give a very brief answer. 0.1. In the year 1975, what is the difference between the General Parity Index (GPI) of East Asia (developing only) and General Parity Index (GPI) of Guatemala?
Keep it short and to the point. 0.49. In the year 1975, what is the difference between the General Parity Index (GPI) in Argentina and General Parity Index (GPI) in Australia?
Give a very brief answer. 0.23. In the year 1975, what is the difference between the General Parity Index (GPI) of Argentina and General Parity Index (GPI) of Guatemala?
Your answer should be compact. 0.63. In the year 1975, what is the difference between the General Parity Index (GPI) of Australia and General Parity Index (GPI) of Guatemala?
Keep it short and to the point. 0.4. In the year 1976, what is the difference between the General Parity Index (GPI) of East Asia (developing only) and General Parity Index (GPI) of Argentina?
Make the answer very short. -0.15. In the year 1976, what is the difference between the General Parity Index (GPI) in East Asia (developing only) and General Parity Index (GPI) in Australia?
Your answer should be very brief. 0.02. In the year 1976, what is the difference between the General Parity Index (GPI) of East Asia (developing only) and General Parity Index (GPI) of Guatemala?
Offer a very short reply. 0.45. In the year 1976, what is the difference between the General Parity Index (GPI) of Argentina and General Parity Index (GPI) of Australia?
Provide a short and direct response. 0.17. In the year 1976, what is the difference between the General Parity Index (GPI) of Argentina and General Parity Index (GPI) of Guatemala?
Your response must be concise. 0.6. In the year 1976, what is the difference between the General Parity Index (GPI) of Australia and General Parity Index (GPI) of Guatemala?
Make the answer very short. 0.43. In the year 1977, what is the difference between the General Parity Index (GPI) in East Asia (developing only) and General Parity Index (GPI) in Argentina?
Offer a very short reply. -0.12. In the year 1977, what is the difference between the General Parity Index (GPI) in East Asia (developing only) and General Parity Index (GPI) in Australia?
Provide a short and direct response. 0.02. In the year 1977, what is the difference between the General Parity Index (GPI) in East Asia (developing only) and General Parity Index (GPI) in Guatemala?
Give a very brief answer. 0.45. In the year 1977, what is the difference between the General Parity Index (GPI) of Argentina and General Parity Index (GPI) of Australia?
Keep it short and to the point. 0.14. In the year 1977, what is the difference between the General Parity Index (GPI) in Argentina and General Parity Index (GPI) in Guatemala?
Offer a very short reply. 0.57. In the year 1977, what is the difference between the General Parity Index (GPI) of Australia and General Parity Index (GPI) of Guatemala?
Offer a very short reply. 0.43. In the year 1978, what is the difference between the General Parity Index (GPI) in East Asia (developing only) and General Parity Index (GPI) in Argentina?
Your answer should be very brief. -0.24. In the year 1978, what is the difference between the General Parity Index (GPI) in East Asia (developing only) and General Parity Index (GPI) in Australia?
Provide a short and direct response. -0.05. In the year 1978, what is the difference between the General Parity Index (GPI) in East Asia (developing only) and General Parity Index (GPI) in Guatemala?
Provide a succinct answer. 0.38. In the year 1978, what is the difference between the General Parity Index (GPI) of Argentina and General Parity Index (GPI) of Australia?
Provide a succinct answer. 0.19. In the year 1978, what is the difference between the General Parity Index (GPI) in Argentina and General Parity Index (GPI) in Guatemala?
Make the answer very short. 0.62. In the year 1978, what is the difference between the General Parity Index (GPI) in Australia and General Parity Index (GPI) in Guatemala?
Offer a very short reply. 0.43. In the year 2002, what is the difference between the General Parity Index (GPI) in East Asia (developing only) and General Parity Index (GPI) in Argentina?
Offer a terse response. -0.59. In the year 2002, what is the difference between the General Parity Index (GPI) of East Asia (developing only) and General Parity Index (GPI) of Australia?
Keep it short and to the point. -0.31. In the year 2002, what is the difference between the General Parity Index (GPI) of East Asia (developing only) and General Parity Index (GPI) of Guatemala?
Provide a short and direct response. 0.18. In the year 2002, what is the difference between the General Parity Index (GPI) of Argentina and General Parity Index (GPI) of Australia?
Your response must be concise. 0.27. In the year 2002, what is the difference between the General Parity Index (GPI) in Argentina and General Parity Index (GPI) in Guatemala?
Keep it short and to the point. 0.77. In the year 2002, what is the difference between the General Parity Index (GPI) in Australia and General Parity Index (GPI) in Guatemala?
Make the answer very short. 0.49. In the year 2007, what is the difference between the General Parity Index (GPI) in East Asia (developing only) and General Parity Index (GPI) in Argentina?
Give a very brief answer. -0.49. In the year 2007, what is the difference between the General Parity Index (GPI) of East Asia (developing only) and General Parity Index (GPI) of Australia?
Your response must be concise. -0.26. In the year 2007, what is the difference between the General Parity Index (GPI) in East Asia (developing only) and General Parity Index (GPI) in Guatemala?
Your response must be concise. 0.03. In the year 2007, what is the difference between the General Parity Index (GPI) of Argentina and General Parity Index (GPI) of Australia?
Provide a succinct answer. 0.23. In the year 2007, what is the difference between the General Parity Index (GPI) of Argentina and General Parity Index (GPI) of Guatemala?
Give a very brief answer. 0.53. In the year 2007, what is the difference between the General Parity Index (GPI) of Australia and General Parity Index (GPI) of Guatemala?
Provide a short and direct response. 0.29. What is the ratio of the General Parity Index (GPI) of East Asia (developing only) in 1973 to that in 1974?
Ensure brevity in your answer.  1.04. What is the ratio of the General Parity Index (GPI) in Argentina in 1973 to that in 1974?
Offer a very short reply. 1.01. What is the ratio of the General Parity Index (GPI) of Australia in 1973 to that in 1974?
Keep it short and to the point. 0.91. What is the ratio of the General Parity Index (GPI) in Guatemala in 1973 to that in 1974?
Provide a short and direct response. 1.04. What is the ratio of the General Parity Index (GPI) in East Asia (developing only) in 1973 to that in 1975?
Make the answer very short. 1.05. What is the ratio of the General Parity Index (GPI) in Argentina in 1973 to that in 1975?
Offer a terse response. 0.92. What is the ratio of the General Parity Index (GPI) in Australia in 1973 to that in 1975?
Keep it short and to the point. 0.84. What is the ratio of the General Parity Index (GPI) in Guatemala in 1973 to that in 1975?
Your answer should be compact. 0.96. What is the ratio of the General Parity Index (GPI) of East Asia (developing only) in 1973 to that in 1976?
Make the answer very short. 1.07. What is the ratio of the General Parity Index (GPI) of Argentina in 1973 to that in 1976?
Ensure brevity in your answer.  0.92. What is the ratio of the General Parity Index (GPI) of Australia in 1973 to that in 1976?
Your answer should be very brief. 0.78. What is the ratio of the General Parity Index (GPI) in Guatemala in 1973 to that in 1976?
Give a very brief answer. 0.89. What is the ratio of the General Parity Index (GPI) of East Asia (developing only) in 1973 to that in 1977?
Keep it short and to the point. 1.06. What is the ratio of the General Parity Index (GPI) of Argentina in 1973 to that in 1977?
Ensure brevity in your answer.  0.93. What is the ratio of the General Parity Index (GPI) in Australia in 1973 to that in 1977?
Your response must be concise. 0.76. What is the ratio of the General Parity Index (GPI) of Guatemala in 1973 to that in 1977?
Provide a short and direct response. 0.85. What is the ratio of the General Parity Index (GPI) in East Asia (developing only) in 1973 to that in 1978?
Offer a terse response. 1.1. What is the ratio of the General Parity Index (GPI) of Argentina in 1973 to that in 1978?
Make the answer very short. 0.86. What is the ratio of the General Parity Index (GPI) of Australia in 1973 to that in 1978?
Your answer should be very brief. 0.73. What is the ratio of the General Parity Index (GPI) in Guatemala in 1973 to that in 1978?
Offer a very short reply. 0.77. What is the ratio of the General Parity Index (GPI) of East Asia (developing only) in 1973 to that in 2002?
Your answer should be very brief. 0.93. What is the ratio of the General Parity Index (GPI) in Argentina in 1973 to that in 2002?
Offer a terse response. 0.57. What is the ratio of the General Parity Index (GPI) in Australia in 1973 to that in 2002?
Provide a short and direct response. 0.49. What is the ratio of the General Parity Index (GPI) in Guatemala in 1973 to that in 2002?
Provide a short and direct response. 0.41. What is the ratio of the General Parity Index (GPI) of East Asia (developing only) in 1973 to that in 2007?
Your answer should be very brief. 0.82. What is the ratio of the General Parity Index (GPI) in Argentina in 1973 to that in 2007?
Your answer should be compact. 0.56. What is the ratio of the General Parity Index (GPI) of Australia in 1973 to that in 2007?
Ensure brevity in your answer.  0.46. What is the ratio of the General Parity Index (GPI) of Guatemala in 1973 to that in 2007?
Your answer should be very brief. 0.29. What is the ratio of the General Parity Index (GPI) of East Asia (developing only) in 1974 to that in 1975?
Keep it short and to the point. 1.01. What is the ratio of the General Parity Index (GPI) in Argentina in 1974 to that in 1975?
Your answer should be compact. 0.91. What is the ratio of the General Parity Index (GPI) of Australia in 1974 to that in 1975?
Provide a succinct answer. 0.93. What is the ratio of the General Parity Index (GPI) of Guatemala in 1974 to that in 1975?
Make the answer very short. 0.92. What is the ratio of the General Parity Index (GPI) in East Asia (developing only) in 1974 to that in 1976?
Your response must be concise. 1.04. What is the ratio of the General Parity Index (GPI) of Argentina in 1974 to that in 1976?
Ensure brevity in your answer.  0.91. What is the ratio of the General Parity Index (GPI) in Australia in 1974 to that in 1976?
Your answer should be compact. 0.86. What is the ratio of the General Parity Index (GPI) in Guatemala in 1974 to that in 1976?
Provide a succinct answer. 0.85. What is the ratio of the General Parity Index (GPI) of East Asia (developing only) in 1974 to that in 1977?
Offer a very short reply. 1.02. What is the ratio of the General Parity Index (GPI) of Argentina in 1974 to that in 1977?
Provide a succinct answer. 0.92. What is the ratio of the General Parity Index (GPI) in Australia in 1974 to that in 1977?
Your answer should be very brief. 0.84. What is the ratio of the General Parity Index (GPI) in Guatemala in 1974 to that in 1977?
Provide a short and direct response. 0.81. What is the ratio of the General Parity Index (GPI) in East Asia (developing only) in 1974 to that in 1978?
Your answer should be compact. 1.07. What is the ratio of the General Parity Index (GPI) of Argentina in 1974 to that in 1978?
Give a very brief answer. 0.85. What is the ratio of the General Parity Index (GPI) in Australia in 1974 to that in 1978?
Your answer should be very brief. 0.81. What is the ratio of the General Parity Index (GPI) in Guatemala in 1974 to that in 1978?
Keep it short and to the point. 0.74. What is the ratio of the General Parity Index (GPI) in East Asia (developing only) in 1974 to that in 2002?
Provide a succinct answer. 0.9. What is the ratio of the General Parity Index (GPI) in Argentina in 1974 to that in 2002?
Your answer should be compact. 0.57. What is the ratio of the General Parity Index (GPI) of Australia in 1974 to that in 2002?
Keep it short and to the point. 0.54. What is the ratio of the General Parity Index (GPI) of Guatemala in 1974 to that in 2002?
Provide a short and direct response. 0.39. What is the ratio of the General Parity Index (GPI) of East Asia (developing only) in 1974 to that in 2007?
Your answer should be compact. 0.79. What is the ratio of the General Parity Index (GPI) of Argentina in 1974 to that in 2007?
Give a very brief answer. 0.56. What is the ratio of the General Parity Index (GPI) of Australia in 1974 to that in 2007?
Your response must be concise. 0.51. What is the ratio of the General Parity Index (GPI) in Guatemala in 1974 to that in 2007?
Offer a terse response. 0.28. What is the ratio of the General Parity Index (GPI) of East Asia (developing only) in 1975 to that in 1976?
Give a very brief answer. 1.02. What is the ratio of the General Parity Index (GPI) in Australia in 1975 to that in 1976?
Give a very brief answer. 0.92. What is the ratio of the General Parity Index (GPI) in Guatemala in 1975 to that in 1976?
Give a very brief answer. 0.93. What is the ratio of the General Parity Index (GPI) of East Asia (developing only) in 1975 to that in 1977?
Give a very brief answer. 1.01. What is the ratio of the General Parity Index (GPI) in Argentina in 1975 to that in 1977?
Offer a very short reply. 1.02. What is the ratio of the General Parity Index (GPI) in Australia in 1975 to that in 1977?
Offer a very short reply. 0.91. What is the ratio of the General Parity Index (GPI) in Guatemala in 1975 to that in 1977?
Give a very brief answer. 0.88. What is the ratio of the General Parity Index (GPI) in East Asia (developing only) in 1975 to that in 1978?
Provide a succinct answer. 1.05. What is the ratio of the General Parity Index (GPI) of Argentina in 1975 to that in 1978?
Provide a succinct answer. 0.93. What is the ratio of the General Parity Index (GPI) of Australia in 1975 to that in 1978?
Make the answer very short. 0.87. What is the ratio of the General Parity Index (GPI) of Guatemala in 1975 to that in 1978?
Provide a succinct answer. 0.8. What is the ratio of the General Parity Index (GPI) of East Asia (developing only) in 1975 to that in 2002?
Your answer should be compact. 0.89. What is the ratio of the General Parity Index (GPI) of Argentina in 1975 to that in 2002?
Make the answer very short. 0.62. What is the ratio of the General Parity Index (GPI) of Australia in 1975 to that in 2002?
Your answer should be compact. 0.58. What is the ratio of the General Parity Index (GPI) of Guatemala in 1975 to that in 2002?
Keep it short and to the point. 0.42. What is the ratio of the General Parity Index (GPI) in East Asia (developing only) in 1975 to that in 2007?
Make the answer very short. 0.78. What is the ratio of the General Parity Index (GPI) in Argentina in 1975 to that in 2007?
Offer a terse response. 0.61. What is the ratio of the General Parity Index (GPI) of Australia in 1975 to that in 2007?
Provide a succinct answer. 0.54. What is the ratio of the General Parity Index (GPI) in Guatemala in 1975 to that in 2007?
Your answer should be compact. 0.31. What is the ratio of the General Parity Index (GPI) of East Asia (developing only) in 1976 to that in 1977?
Make the answer very short. 0.99. What is the ratio of the General Parity Index (GPI) of Argentina in 1976 to that in 1977?
Your answer should be very brief. 1.01. What is the ratio of the General Parity Index (GPI) in Australia in 1976 to that in 1977?
Offer a very short reply. 0.98. What is the ratio of the General Parity Index (GPI) of Guatemala in 1976 to that in 1977?
Ensure brevity in your answer.  0.95. What is the ratio of the General Parity Index (GPI) in East Asia (developing only) in 1976 to that in 1978?
Ensure brevity in your answer.  1.03. What is the ratio of the General Parity Index (GPI) of Argentina in 1976 to that in 1978?
Provide a short and direct response. 0.93. What is the ratio of the General Parity Index (GPI) of Australia in 1976 to that in 1978?
Provide a short and direct response. 0.94. What is the ratio of the General Parity Index (GPI) of Guatemala in 1976 to that in 1978?
Provide a succinct answer. 0.87. What is the ratio of the General Parity Index (GPI) of East Asia (developing only) in 1976 to that in 2002?
Give a very brief answer. 0.87. What is the ratio of the General Parity Index (GPI) in Argentina in 1976 to that in 2002?
Your answer should be very brief. 0.62. What is the ratio of the General Parity Index (GPI) of Australia in 1976 to that in 2002?
Offer a very short reply. 0.63. What is the ratio of the General Parity Index (GPI) in Guatemala in 1976 to that in 2002?
Your answer should be very brief. 0.46. What is the ratio of the General Parity Index (GPI) in East Asia (developing only) in 1976 to that in 2007?
Give a very brief answer. 0.76. What is the ratio of the General Parity Index (GPI) of Argentina in 1976 to that in 2007?
Your answer should be compact. 0.61. What is the ratio of the General Parity Index (GPI) of Australia in 1976 to that in 2007?
Your answer should be very brief. 0.59. What is the ratio of the General Parity Index (GPI) in Guatemala in 1976 to that in 2007?
Give a very brief answer. 0.33. What is the ratio of the General Parity Index (GPI) in East Asia (developing only) in 1977 to that in 1978?
Provide a succinct answer. 1.04. What is the ratio of the General Parity Index (GPI) of Argentina in 1977 to that in 1978?
Your response must be concise. 0.92. What is the ratio of the General Parity Index (GPI) in Australia in 1977 to that in 1978?
Your response must be concise. 0.96. What is the ratio of the General Parity Index (GPI) of Guatemala in 1977 to that in 1978?
Your answer should be very brief. 0.91. What is the ratio of the General Parity Index (GPI) in East Asia (developing only) in 1977 to that in 2002?
Offer a very short reply. 0.88. What is the ratio of the General Parity Index (GPI) of Argentina in 1977 to that in 2002?
Ensure brevity in your answer.  0.62. What is the ratio of the General Parity Index (GPI) of Australia in 1977 to that in 2002?
Provide a short and direct response. 0.64. What is the ratio of the General Parity Index (GPI) in Guatemala in 1977 to that in 2002?
Offer a terse response. 0.48. What is the ratio of the General Parity Index (GPI) of East Asia (developing only) in 1977 to that in 2007?
Your answer should be very brief. 0.77. What is the ratio of the General Parity Index (GPI) in Argentina in 1977 to that in 2007?
Your answer should be very brief. 0.6. What is the ratio of the General Parity Index (GPI) in Australia in 1977 to that in 2007?
Your answer should be compact. 0.6. What is the ratio of the General Parity Index (GPI) in Guatemala in 1977 to that in 2007?
Make the answer very short. 0.35. What is the ratio of the General Parity Index (GPI) of East Asia (developing only) in 1978 to that in 2002?
Give a very brief answer. 0.84. What is the ratio of the General Parity Index (GPI) of Argentina in 1978 to that in 2002?
Your answer should be compact. 0.67. What is the ratio of the General Parity Index (GPI) in Australia in 1978 to that in 2002?
Keep it short and to the point. 0.66. What is the ratio of the General Parity Index (GPI) of Guatemala in 1978 to that in 2002?
Give a very brief answer. 0.53. What is the ratio of the General Parity Index (GPI) of East Asia (developing only) in 1978 to that in 2007?
Your answer should be very brief. 0.74. What is the ratio of the General Parity Index (GPI) of Argentina in 1978 to that in 2007?
Your answer should be compact. 0.65. What is the ratio of the General Parity Index (GPI) of Australia in 1978 to that in 2007?
Provide a short and direct response. 0.63. What is the ratio of the General Parity Index (GPI) in Guatemala in 1978 to that in 2007?
Your answer should be compact. 0.38. What is the ratio of the General Parity Index (GPI) of East Asia (developing only) in 2002 to that in 2007?
Offer a terse response. 0.88. What is the ratio of the General Parity Index (GPI) in Argentina in 2002 to that in 2007?
Make the answer very short. 0.98. What is the ratio of the General Parity Index (GPI) of Australia in 2002 to that in 2007?
Your answer should be very brief. 0.94. What is the ratio of the General Parity Index (GPI) in Guatemala in 2002 to that in 2007?
Provide a short and direct response. 0.73. What is the difference between the highest and the second highest General Parity Index (GPI) of East Asia (developing only)?
Your answer should be very brief. 0.13. What is the difference between the highest and the second highest General Parity Index (GPI) in Argentina?
Give a very brief answer. 0.03. What is the difference between the highest and the second highest General Parity Index (GPI) of Australia?
Offer a terse response. 0.07. What is the difference between the highest and the second highest General Parity Index (GPI) in Guatemala?
Your response must be concise. 0.27. What is the difference between the highest and the lowest General Parity Index (GPI) of East Asia (developing only)?
Provide a succinct answer. 0.27. What is the difference between the highest and the lowest General Parity Index (GPI) in Argentina?
Give a very brief answer. 0.68. What is the difference between the highest and the lowest General Parity Index (GPI) in Australia?
Offer a very short reply. 0.7. What is the difference between the highest and the lowest General Parity Index (GPI) in Guatemala?
Your response must be concise. 0.72. 